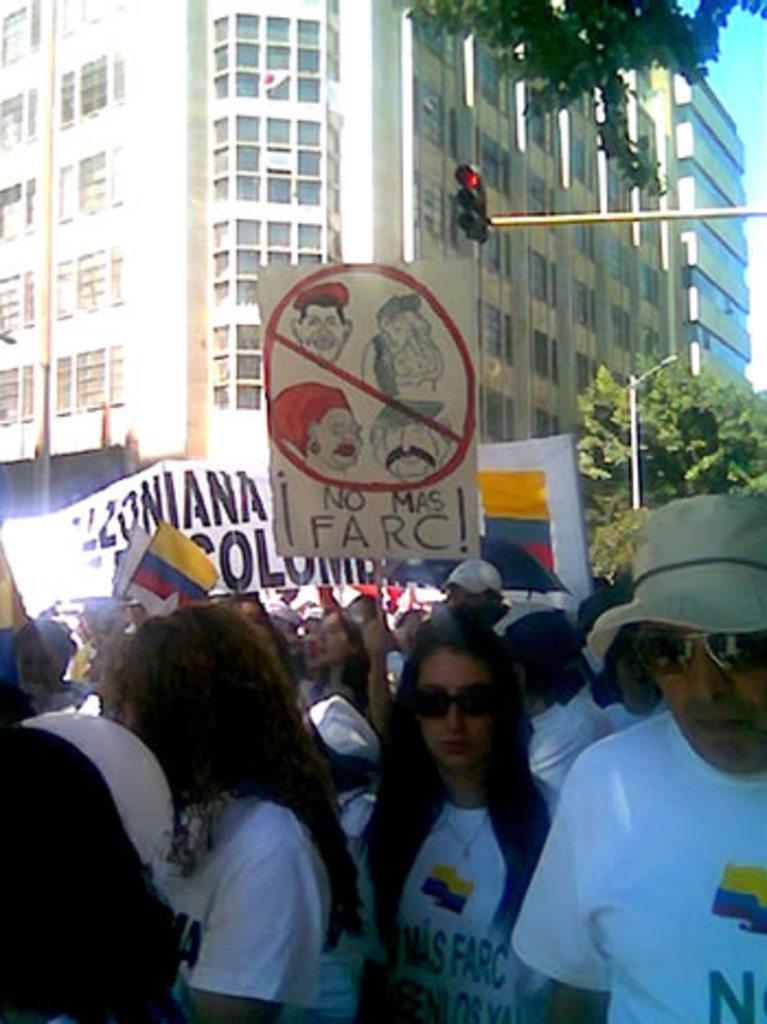Please provide a concise description of this image. This image consists of buildings along with windows. At the bottom, there is a huge crowd. And we can see the placards and banners. On the right, there are trees and signal lights. 